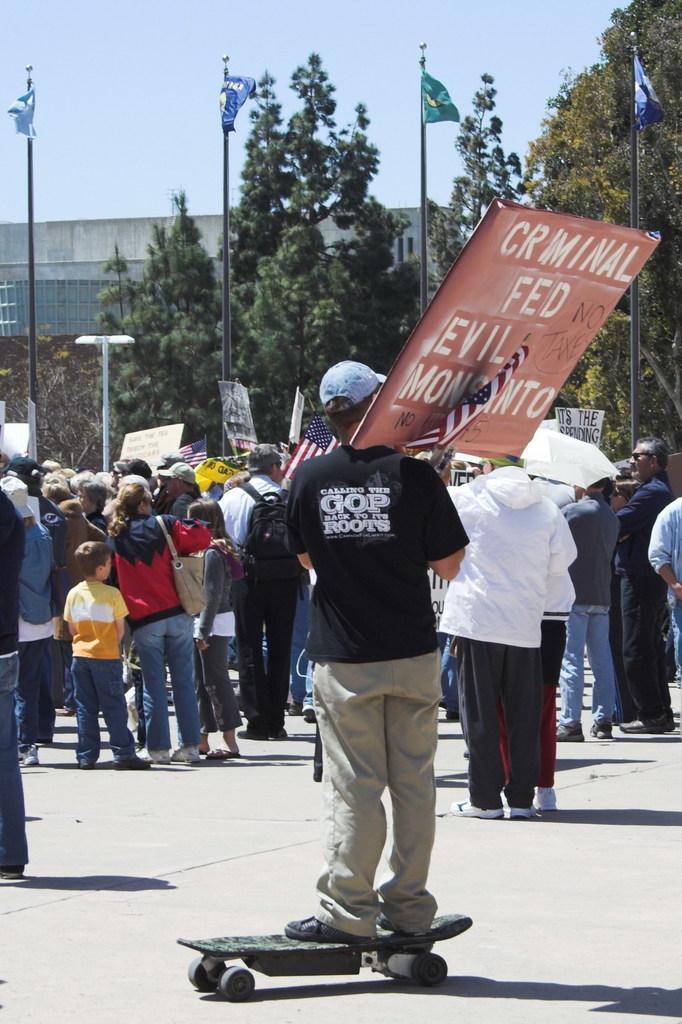Describe this image in one or two sentences. Here a person is standing on the skateboard and holding banner and flag and wearing a cap. Here we can see a group of people are standing on the road. Few are wearing bags. Background there are so many trees, building, poles, flags and light. Top of the image, there is a sky. 